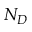<formula> <loc_0><loc_0><loc_500><loc_500>N _ { D }</formula> 